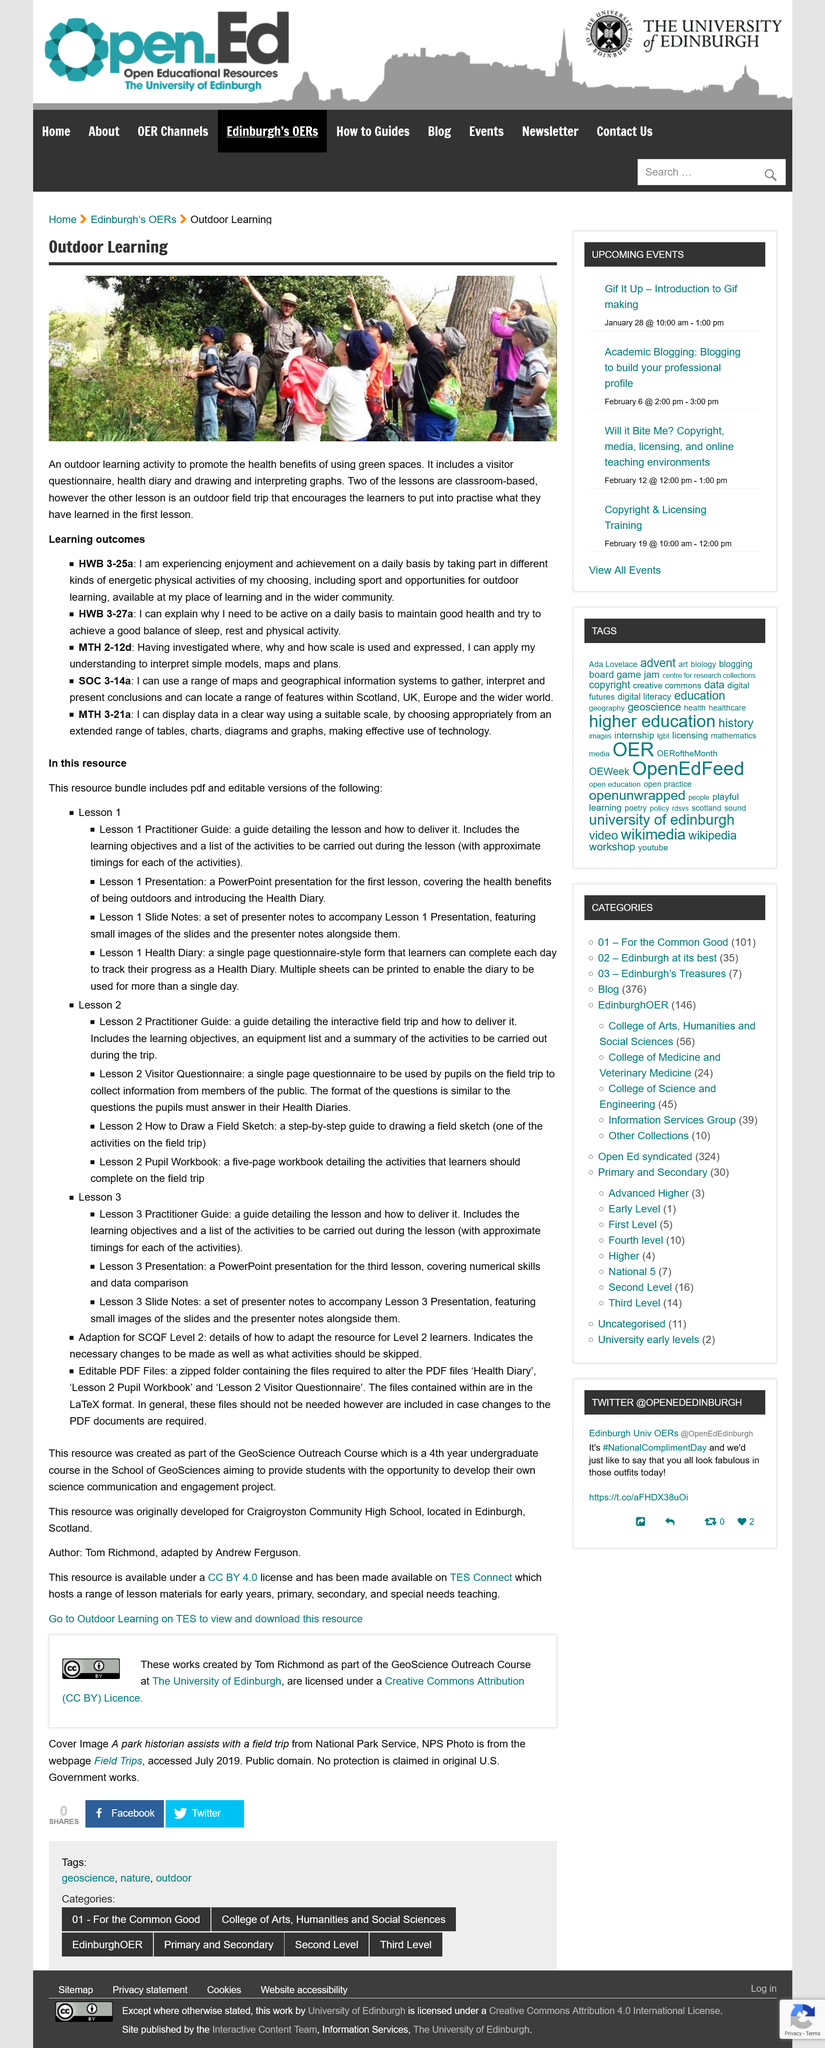Mention a couple of crucial points in this snapshot. Outdoor learning activities can incorporate visitor questionnaires, health diaries, and the creation and interpretation of graphs. Yes, Lesson 1 is one of the things found in this resource. It is well established that engaging in daily physical activity and utilizing green spaces has a significant impact on maintaining good health. Yes, the health benefits of being outdoors are included in Lesson 1 presentation. The Lesson 1 Health Diary form is a single-page document that is utilized for an extended period of time. 